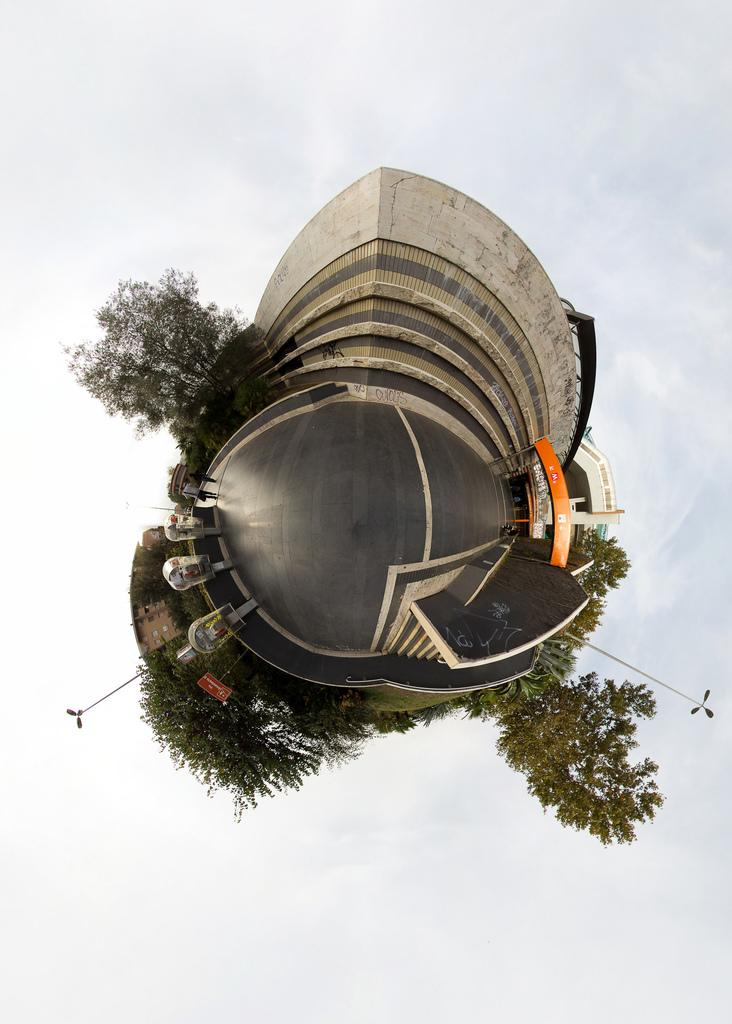What is the main subject of the image? The main subject of the image is an edited image in the middle. What does the edited image appear to represent? The edited image appears to be a building. What type of natural environment is visible in the image? There are trees in the image. What type of food is being cooked in the image? There is no indication of cooking or any food in the image. 